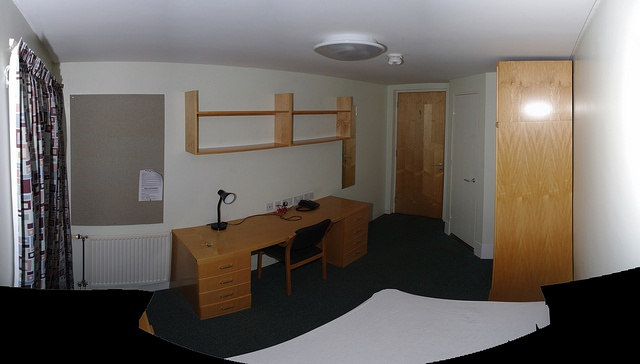Describe the objects in this image and their specific colors. I can see bed in darkgray, black, gray, and maroon tones and chair in darkgray, black, and maroon tones in this image. 